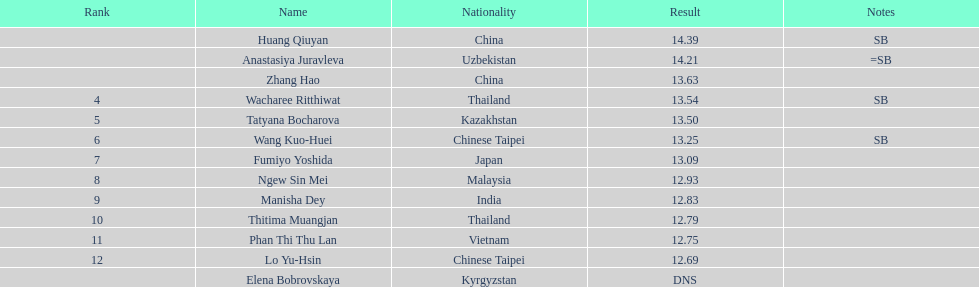Which country had the most competitors ranked in the top three in the event? China. 